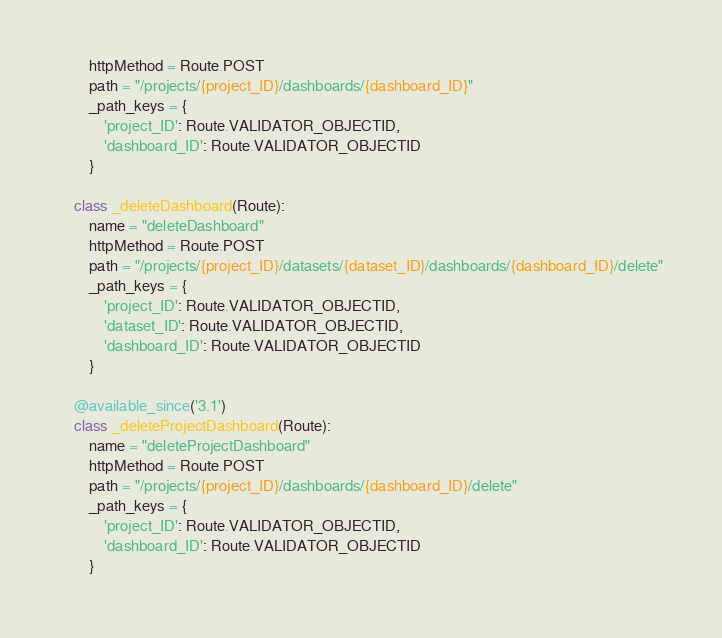Convert code to text. <code><loc_0><loc_0><loc_500><loc_500><_Python_>        httpMethod = Route.POST
        path = "/projects/{project_ID}/dashboards/{dashboard_ID}"
        _path_keys = {
            'project_ID': Route.VALIDATOR_OBJECTID,
            'dashboard_ID': Route.VALIDATOR_OBJECTID
        }

    class _deleteDashboard(Route):
        name = "deleteDashboard"
        httpMethod = Route.POST
        path = "/projects/{project_ID}/datasets/{dataset_ID}/dashboards/{dashboard_ID}/delete"
        _path_keys = {
            'project_ID': Route.VALIDATOR_OBJECTID,
            'dataset_ID': Route.VALIDATOR_OBJECTID,
            'dashboard_ID': Route.VALIDATOR_OBJECTID
        }

    @available_since('3.1')
    class _deleteProjectDashboard(Route):
        name = "deleteProjectDashboard"
        httpMethod = Route.POST
        path = "/projects/{project_ID}/dashboards/{dashboard_ID}/delete"
        _path_keys = {
            'project_ID': Route.VALIDATOR_OBJECTID,
            'dashboard_ID': Route.VALIDATOR_OBJECTID
        }
</code> 